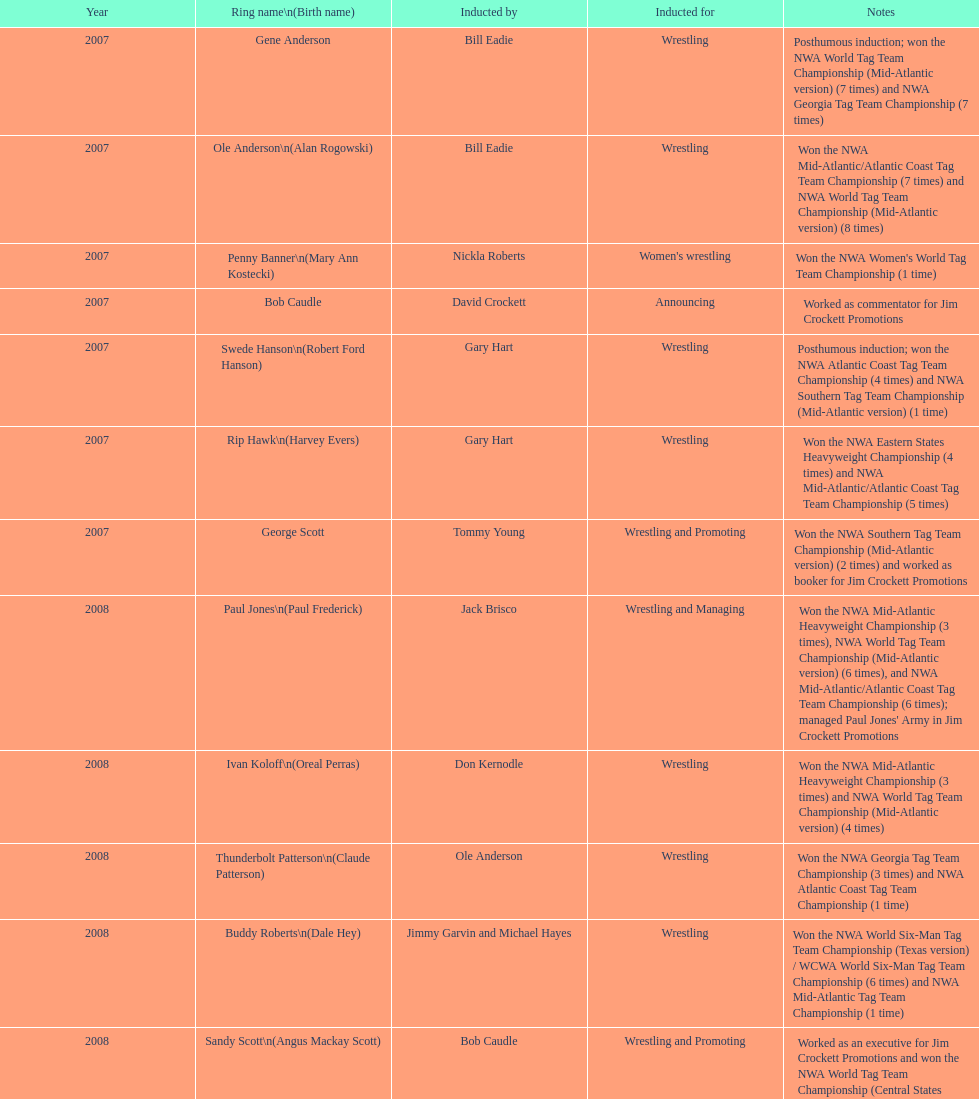What number of members were inducted before 2009? 14. 